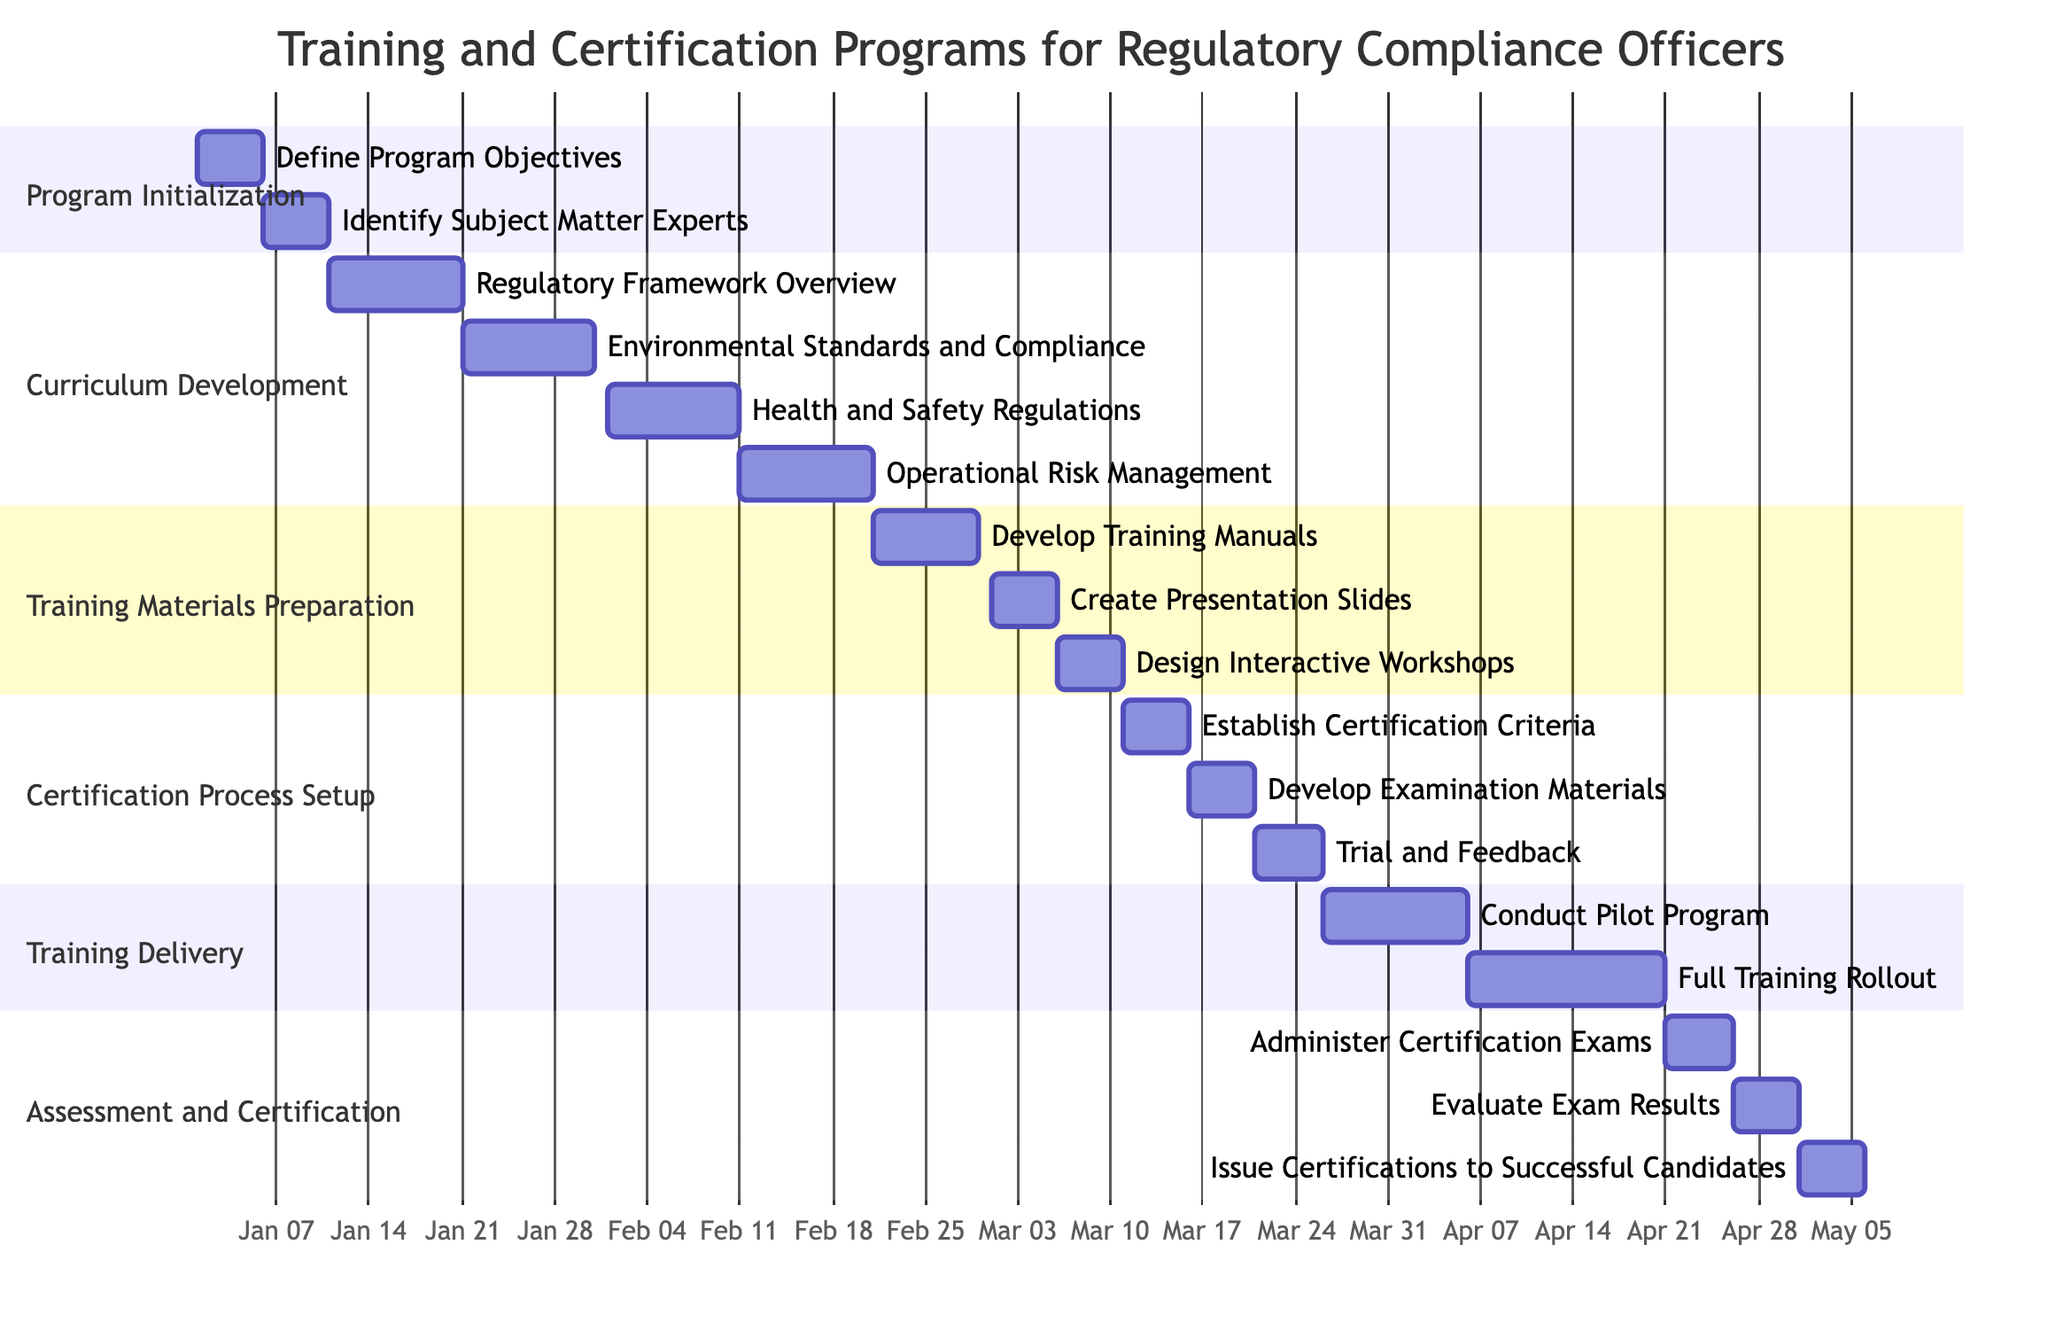What is the duration of the Program Initialization phase? The Program Initialization phase consists of two tasks: "Define Program Objectives" which lasts for 5 days and "Identify Subject Matter Experts" which lasts for another 5 days. Since both tasks are sequential, the total duration is the sum of these two: 5 days + 5 days = 10 days.
Answer: 10 days What starts after the Environmental Standards and Compliance task? The Environmental Standards and Compliance task ends on January 30, 2024. The next task that starts after this date is "Health and Safety Regulations," which begins on February 1, 2024, immediately after the end of the previous task.
Answer: Health and Safety Regulations How many tasks are there in the Training Delivery section? The Training Delivery section includes two tasks: "Conduct Pilot Program" and "Full Training Rollout." Counting these two tasks, we find there are a total of 2 tasks in this section.
Answer: 2 tasks Which task has the latest start date in the diagram? To determine the task with the latest start date, we need to look at the start dates for all tasks. The last task to start is "Issue Certifications to Successful Candidates," which begins on May 1, 2024.
Answer: Issue Certifications to Successful Candidates How many total days does the Assessment and Certification section cover? The Assessment and Certification section consists of three tasks: "Administer Certification Exams" (5 days), "Evaluate Exam Results" (5 days), and "Issue Certifications to Successful Candidates" (5 days). Adding these together, the total duration is 5 days + 5 days + 5 days = 15 days.
Answer: 15 days What is the gap between the end of the Curriculum Development phase and the beginning of Training Delivery? The Curriculum Development phase ends on February 20, 2024, while the Training Delivery phase starts with the "Conduct Pilot Program" on March 26, 2024. The gap between these two dates can be calculated as 26 days (from February 20 to March 26).
Answer: 26 days Which task is dependent on the establishment of certification criteria? The task that follows the "Establish Certification Criteria" is "Develop Examination Materials," which cannot begin until the criteria are established. Therefore, it is directly dependent on the completion of that task.
Answer: Develop Examination Materials What does the arrow indicate in a Gantt chart? In a Gantt chart, arrows typically indicate dependencies between tasks, meaning that one task cannot start until another task is completed. This represents the flow of work and task interdependencies visually.
Answer: Dependencies between tasks 